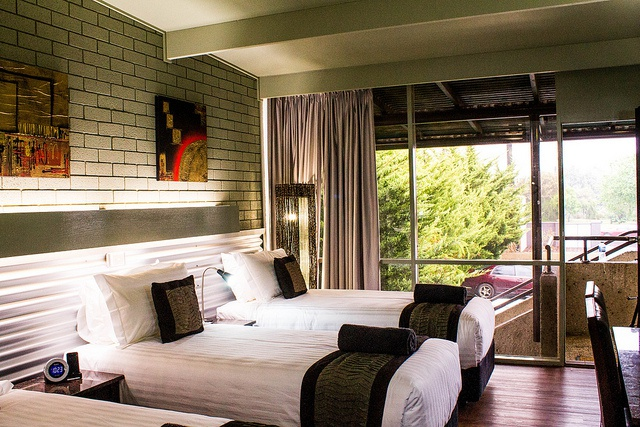Describe the objects in this image and their specific colors. I can see bed in darkgreen, lightgray, black, darkgray, and tan tones, bed in darkgreen, lightgray, black, darkgray, and tan tones, bed in darkgreen, tan, lightgray, and black tones, chair in darkgreen, black, lavender, maroon, and brown tones, and car in darkgreen, lavender, brown, and maroon tones in this image. 